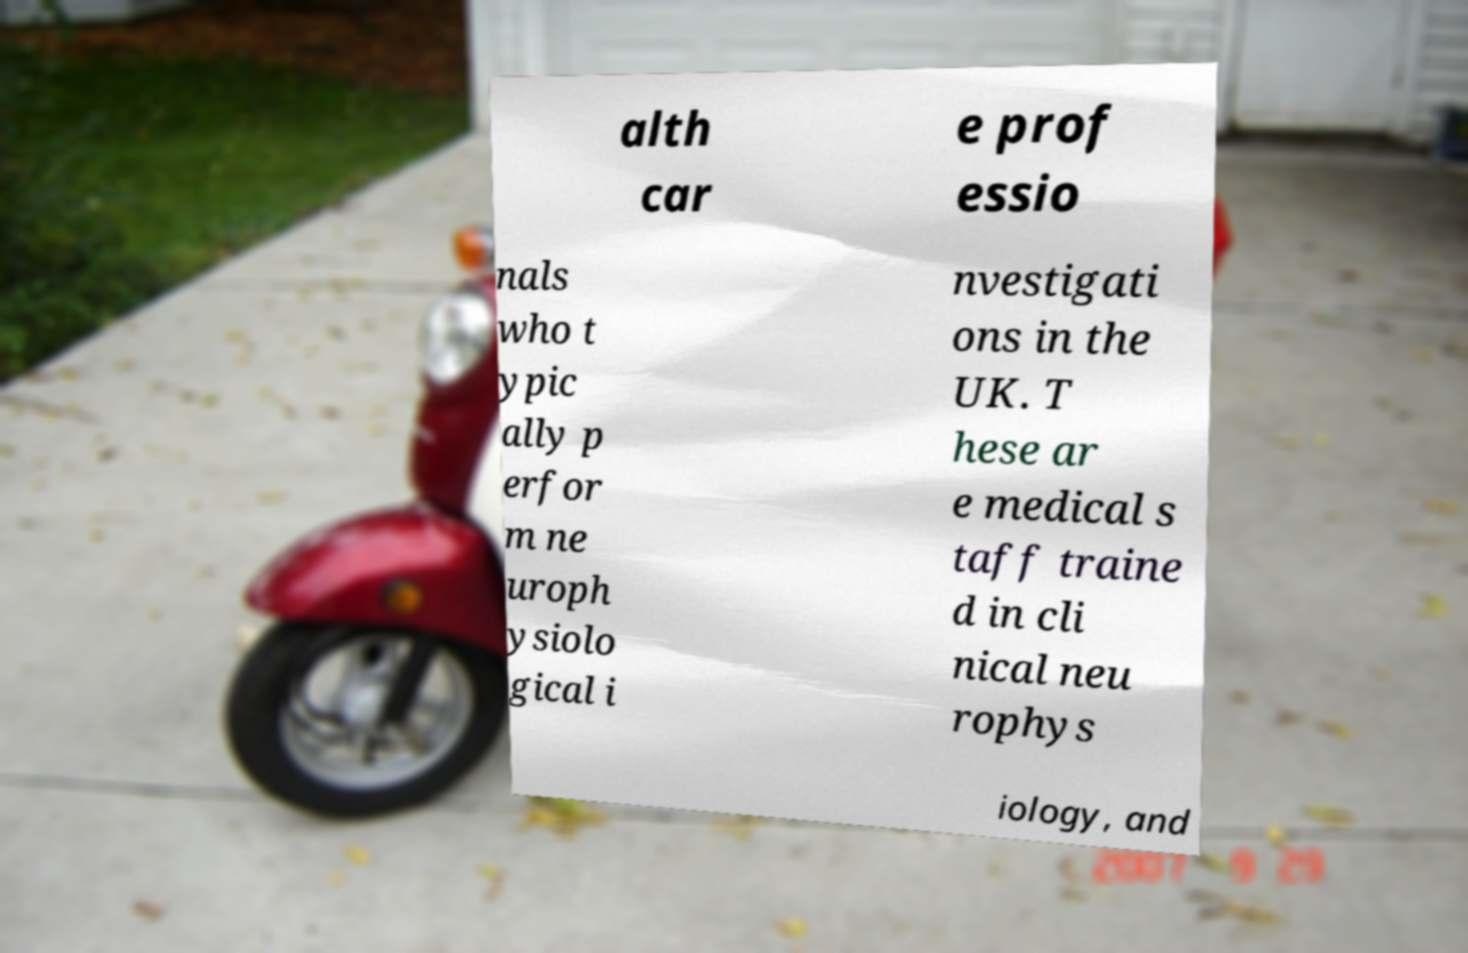Could you extract and type out the text from this image? alth car e prof essio nals who t ypic ally p erfor m ne uroph ysiolo gical i nvestigati ons in the UK. T hese ar e medical s taff traine d in cli nical neu rophys iology, and 